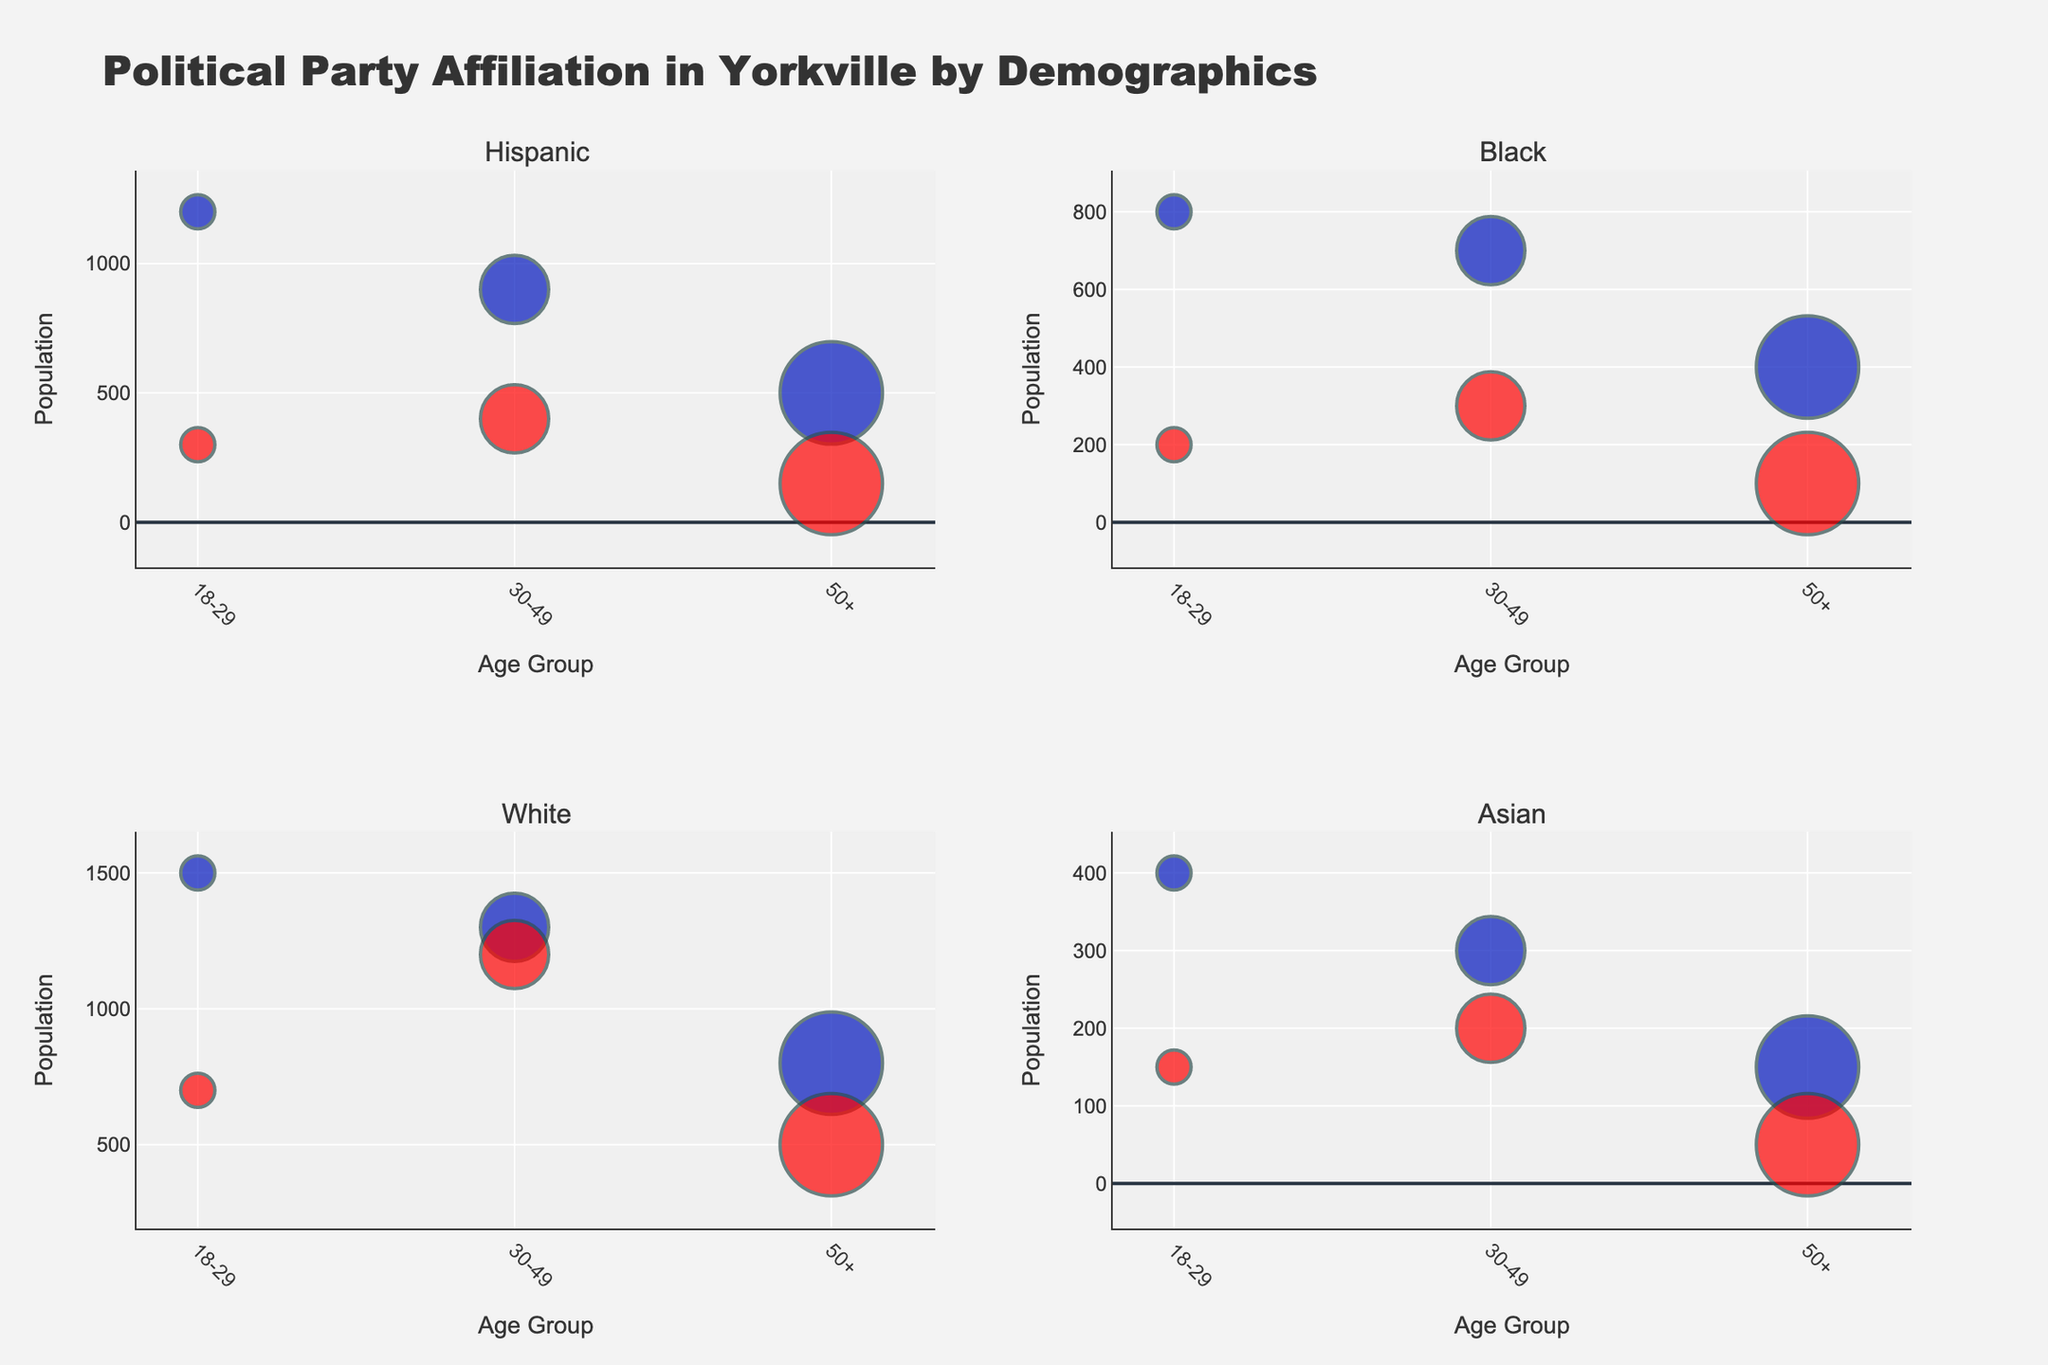What is the title of the figure? The title is displayed prominently at the top of the figure and is usually in a larger font. Look for text that summarizes the plot.
Answer: Political Party Affiliation in Yorkville by Demographics Which age group has the highest population among Republican White individuals? Identify the subplot for White demographics and then examine the Republican data points. Look for the largest bubble in terms of the y-axis value that corresponds to population.
Answer: 30-49 How many subplots are there in the figure? Count the distinct charts within the larger figure. Each subplot title represents a different demographic.
Answer: 4 In the Hispanic Democratic demographic, which age group has the smallest population? In the Hispanic Democratic subplot, find the smallest bubble in terms of the y-axis value, which corresponds to the population.
Answer: 50+ Compare the sizes of Republican and Democratic bubbles for the Asian 30-49 age group. Which one is larger and why? Look at the Asian subplot, identify the bubbles for the 30-49 age group for both parties, compare the sizes of the bubbles which represent income levels.
Answer: Republican is larger due to higher income What color represents the Democratic Party? Identify the bubbles associated with the Democratic Party across different subplots and note their color.
Answer: Blue For the Black demographic, which party has a higher population in the 18-29 age group? Focus on the Black demographic subplot and compare the y-axis values of the Democratic and Republican bubbles in the 18-29 age group.
Answer: Democratic Which demographic shows the least population in the Republican 50+ age group? Compare the y-axis values of the Republican bubbles for the 50+ age group across all subplots to find the smallest one.
Answer: Asian What is the income level of the largest bubble in the White Democratic 30-49 age group? Identify the largest bubble in the White Democratic subplot for the 30-49 age group and check the bubble's hover text, which displays the income level.
Answer: Medium What pattern, if any, do you observe in the population distribution across age groups within the Hispanic Democratic demographic? Examine the Hispanic Democratic subplot and describe how the population changes from one age group to another.
Answer: Decreases with age 